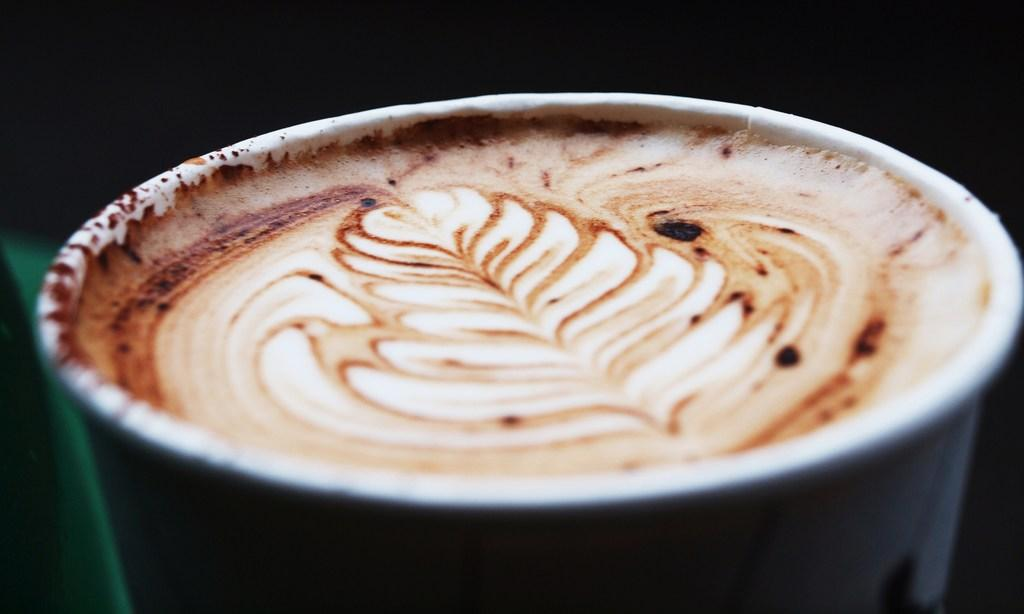What is in the cup that is visible in the image? There is a cup with coffee in the image. What can be seen in the background of the image? The background of the image is dark. What type of riddle is hidden in the coffee cup in the image? There is no riddle hidden in the coffee cup in the image; it is simply a cup of coffee. 